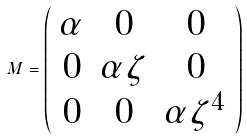Convert formula to latex. <formula><loc_0><loc_0><loc_500><loc_500>M = \left ( \begin{array} { c c c } \alpha & 0 & 0 \\ 0 & \alpha \zeta & 0 \\ 0 & 0 & \alpha \zeta ^ { 4 } \\ \end{array} \right )</formula> 